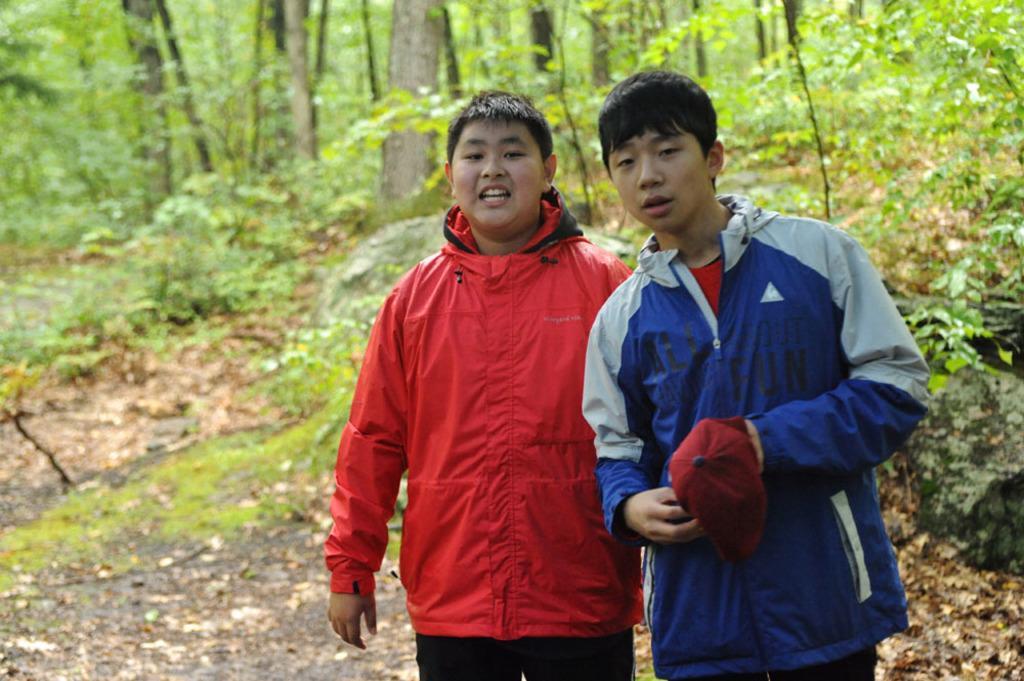Can you describe this image briefly? In this image there are persons standing in the front. In the background there are trees and there is grass on the ground and there are dry leaves on the ground. 